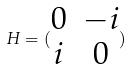<formula> <loc_0><loc_0><loc_500><loc_500>H = ( \begin{matrix} 0 & - i \\ i & 0 \end{matrix} )</formula> 